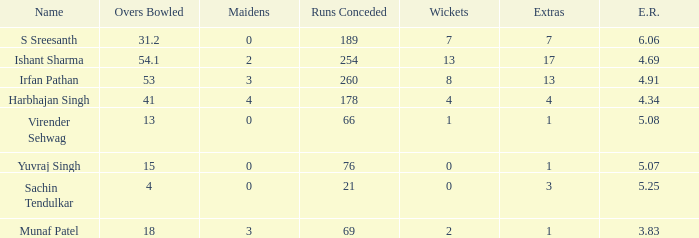Name the name for when overs bowled is 31.2 S Sreesanth. 